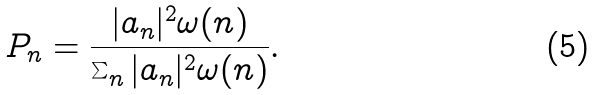Convert formula to latex. <formula><loc_0><loc_0><loc_500><loc_500>P _ { n } = \frac { | a _ { n } | ^ { 2 } \omega ( n ) } { \sum _ { n } | a _ { n } | ^ { 2 } \omega ( n ) } .</formula> 